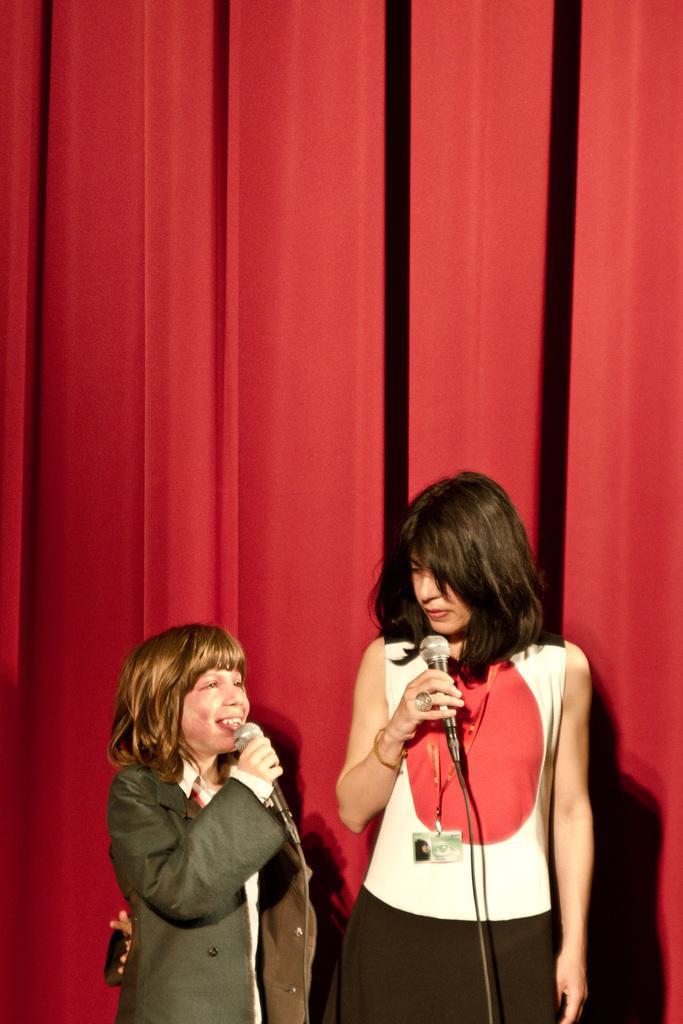Describe this image in one or two sentences. On the background we can see red colour curtain. Here we can see a woman and a girl holding mics in their hands and this girl is talking. 